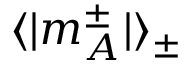<formula> <loc_0><loc_0><loc_500><loc_500>\langle | m _ { A } ^ { \pm } | \rangle _ { \pm }</formula> 